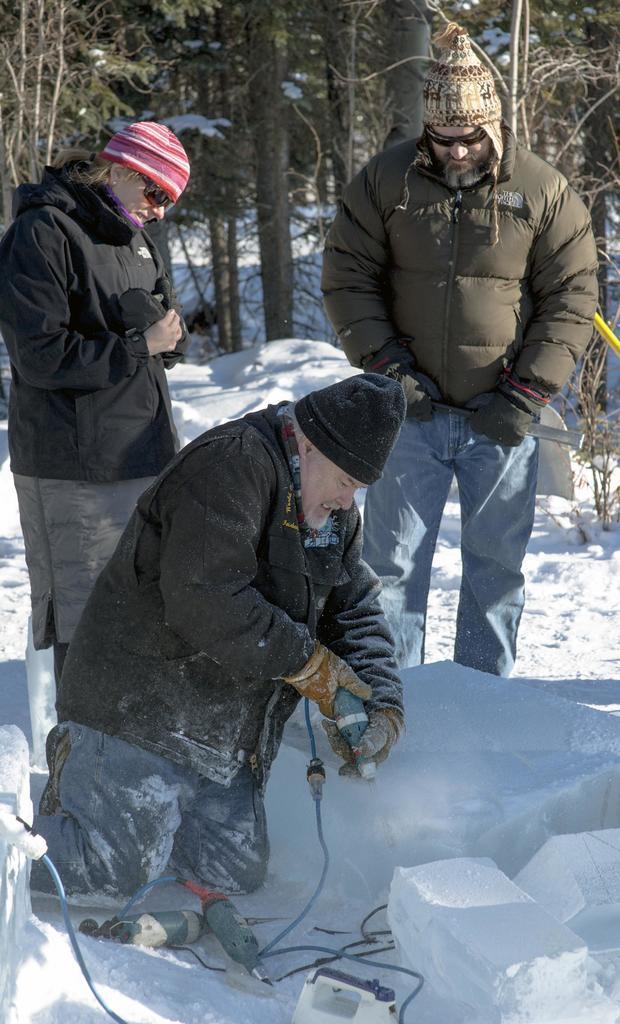Please provide a concise description of this image. In this image there is a person using a drilling machine is cutting the snow, in front of him there are two other drilling machines with cables, behind the person there are two people standing, behind them there are trees. 